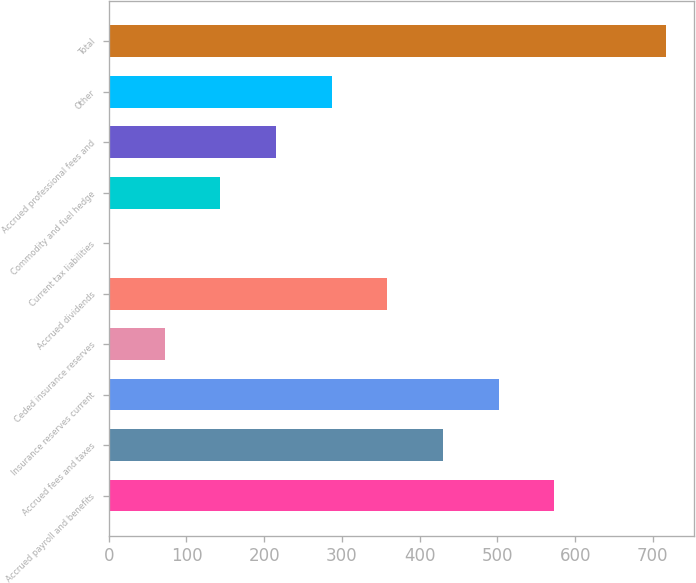Convert chart. <chart><loc_0><loc_0><loc_500><loc_500><bar_chart><fcel>Accrued payroll and benefits<fcel>Accrued fees and taxes<fcel>Insurance reserves current<fcel>Ceded insurance reserves<fcel>Accrued dividends<fcel>Current tax liabilities<fcel>Commodity and fuel hedge<fcel>Accrued professional fees and<fcel>Other<fcel>Total<nl><fcel>573.38<fcel>430.16<fcel>501.77<fcel>72.11<fcel>358.55<fcel>0.5<fcel>143.72<fcel>215.33<fcel>286.94<fcel>716.6<nl></chart> 